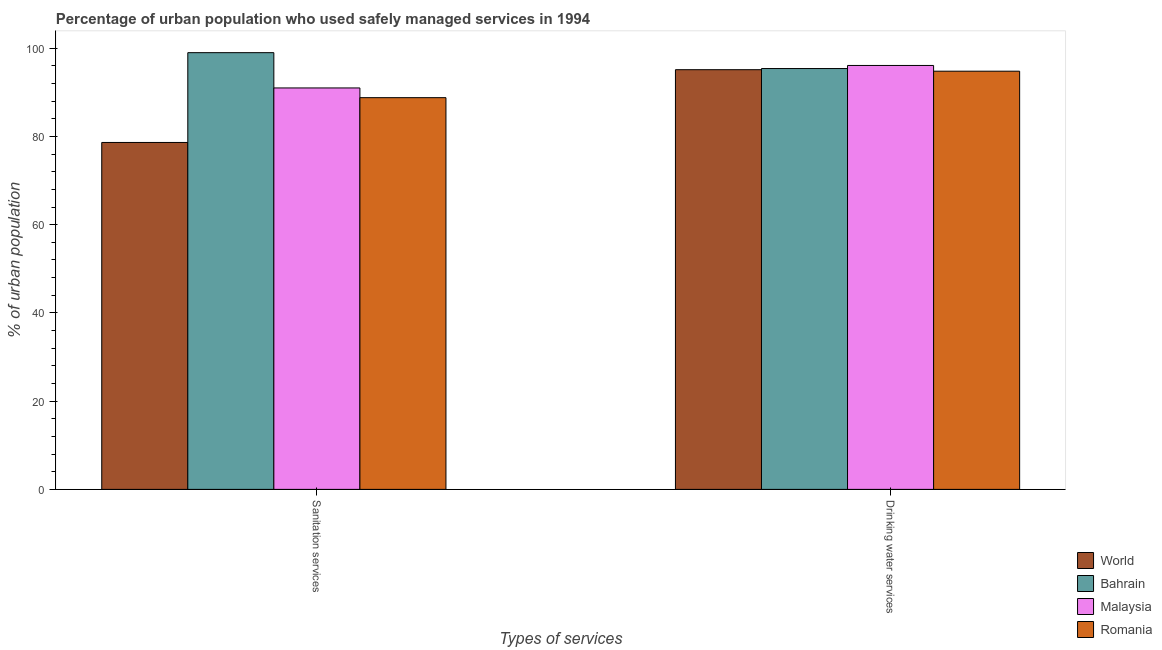How many different coloured bars are there?
Make the answer very short. 4. Are the number of bars per tick equal to the number of legend labels?
Provide a short and direct response. Yes. Are the number of bars on each tick of the X-axis equal?
Your response must be concise. Yes. What is the label of the 1st group of bars from the left?
Keep it short and to the point. Sanitation services. What is the percentage of urban population who used sanitation services in World?
Ensure brevity in your answer.  78.64. Across all countries, what is the minimum percentage of urban population who used drinking water services?
Keep it short and to the point. 94.8. In which country was the percentage of urban population who used sanitation services maximum?
Provide a succinct answer. Bahrain. In which country was the percentage of urban population who used sanitation services minimum?
Provide a succinct answer. World. What is the total percentage of urban population who used drinking water services in the graph?
Your answer should be very brief. 381.44. What is the difference between the percentage of urban population who used drinking water services in World and that in Bahrain?
Keep it short and to the point. -0.26. What is the difference between the percentage of urban population who used drinking water services in World and the percentage of urban population who used sanitation services in Bahrain?
Give a very brief answer. -3.86. What is the average percentage of urban population who used drinking water services per country?
Make the answer very short. 95.36. What is the difference between the percentage of urban population who used drinking water services and percentage of urban population who used sanitation services in World?
Your response must be concise. 16.5. What is the ratio of the percentage of urban population who used sanitation services in Malaysia to that in Bahrain?
Make the answer very short. 0.92. What does the 4th bar from the left in Sanitation services represents?
Give a very brief answer. Romania. What does the 1st bar from the right in Drinking water services represents?
Give a very brief answer. Romania. How many bars are there?
Your answer should be very brief. 8. Are all the bars in the graph horizontal?
Provide a short and direct response. No. How many countries are there in the graph?
Provide a short and direct response. 4. Does the graph contain any zero values?
Offer a terse response. No. How many legend labels are there?
Keep it short and to the point. 4. What is the title of the graph?
Your answer should be very brief. Percentage of urban population who used safely managed services in 1994. Does "Sub-Saharan Africa (all income levels)" appear as one of the legend labels in the graph?
Your answer should be compact. No. What is the label or title of the X-axis?
Provide a short and direct response. Types of services. What is the label or title of the Y-axis?
Provide a succinct answer. % of urban population. What is the % of urban population in World in Sanitation services?
Provide a succinct answer. 78.64. What is the % of urban population of Malaysia in Sanitation services?
Provide a succinct answer. 91. What is the % of urban population in Romania in Sanitation services?
Give a very brief answer. 88.8. What is the % of urban population of World in Drinking water services?
Your answer should be compact. 95.14. What is the % of urban population of Bahrain in Drinking water services?
Ensure brevity in your answer.  95.4. What is the % of urban population in Malaysia in Drinking water services?
Ensure brevity in your answer.  96.1. What is the % of urban population of Romania in Drinking water services?
Make the answer very short. 94.8. Across all Types of services, what is the maximum % of urban population of World?
Your answer should be compact. 95.14. Across all Types of services, what is the maximum % of urban population in Bahrain?
Your response must be concise. 99. Across all Types of services, what is the maximum % of urban population of Malaysia?
Offer a very short reply. 96.1. Across all Types of services, what is the maximum % of urban population of Romania?
Your answer should be compact. 94.8. Across all Types of services, what is the minimum % of urban population of World?
Offer a very short reply. 78.64. Across all Types of services, what is the minimum % of urban population in Bahrain?
Your answer should be compact. 95.4. Across all Types of services, what is the minimum % of urban population of Malaysia?
Provide a succinct answer. 91. Across all Types of services, what is the minimum % of urban population in Romania?
Keep it short and to the point. 88.8. What is the total % of urban population in World in the graph?
Make the answer very short. 173.78. What is the total % of urban population of Bahrain in the graph?
Offer a very short reply. 194.4. What is the total % of urban population of Malaysia in the graph?
Offer a terse response. 187.1. What is the total % of urban population of Romania in the graph?
Make the answer very short. 183.6. What is the difference between the % of urban population in World in Sanitation services and that in Drinking water services?
Provide a succinct answer. -16.5. What is the difference between the % of urban population in Malaysia in Sanitation services and that in Drinking water services?
Give a very brief answer. -5.1. What is the difference between the % of urban population in Romania in Sanitation services and that in Drinking water services?
Provide a succinct answer. -6. What is the difference between the % of urban population in World in Sanitation services and the % of urban population in Bahrain in Drinking water services?
Provide a succinct answer. -16.76. What is the difference between the % of urban population of World in Sanitation services and the % of urban population of Malaysia in Drinking water services?
Provide a succinct answer. -17.46. What is the difference between the % of urban population in World in Sanitation services and the % of urban population in Romania in Drinking water services?
Your response must be concise. -16.16. What is the average % of urban population of World per Types of services?
Give a very brief answer. 86.89. What is the average % of urban population of Bahrain per Types of services?
Ensure brevity in your answer.  97.2. What is the average % of urban population in Malaysia per Types of services?
Make the answer very short. 93.55. What is the average % of urban population of Romania per Types of services?
Give a very brief answer. 91.8. What is the difference between the % of urban population in World and % of urban population in Bahrain in Sanitation services?
Offer a very short reply. -20.36. What is the difference between the % of urban population of World and % of urban population of Malaysia in Sanitation services?
Your answer should be very brief. -12.36. What is the difference between the % of urban population of World and % of urban population of Romania in Sanitation services?
Your answer should be very brief. -10.16. What is the difference between the % of urban population of Bahrain and % of urban population of Romania in Sanitation services?
Your answer should be compact. 10.2. What is the difference between the % of urban population in World and % of urban population in Bahrain in Drinking water services?
Ensure brevity in your answer.  -0.26. What is the difference between the % of urban population in World and % of urban population in Malaysia in Drinking water services?
Your answer should be compact. -0.96. What is the difference between the % of urban population in World and % of urban population in Romania in Drinking water services?
Ensure brevity in your answer.  0.34. What is the difference between the % of urban population in Bahrain and % of urban population in Romania in Drinking water services?
Provide a short and direct response. 0.6. What is the difference between the % of urban population in Malaysia and % of urban population in Romania in Drinking water services?
Your answer should be compact. 1.3. What is the ratio of the % of urban population of World in Sanitation services to that in Drinking water services?
Offer a very short reply. 0.83. What is the ratio of the % of urban population in Bahrain in Sanitation services to that in Drinking water services?
Your answer should be very brief. 1.04. What is the ratio of the % of urban population in Malaysia in Sanitation services to that in Drinking water services?
Offer a terse response. 0.95. What is the ratio of the % of urban population of Romania in Sanitation services to that in Drinking water services?
Your answer should be very brief. 0.94. What is the difference between the highest and the second highest % of urban population in World?
Provide a short and direct response. 16.5. What is the difference between the highest and the lowest % of urban population in World?
Your response must be concise. 16.5. What is the difference between the highest and the lowest % of urban population in Romania?
Provide a short and direct response. 6. 